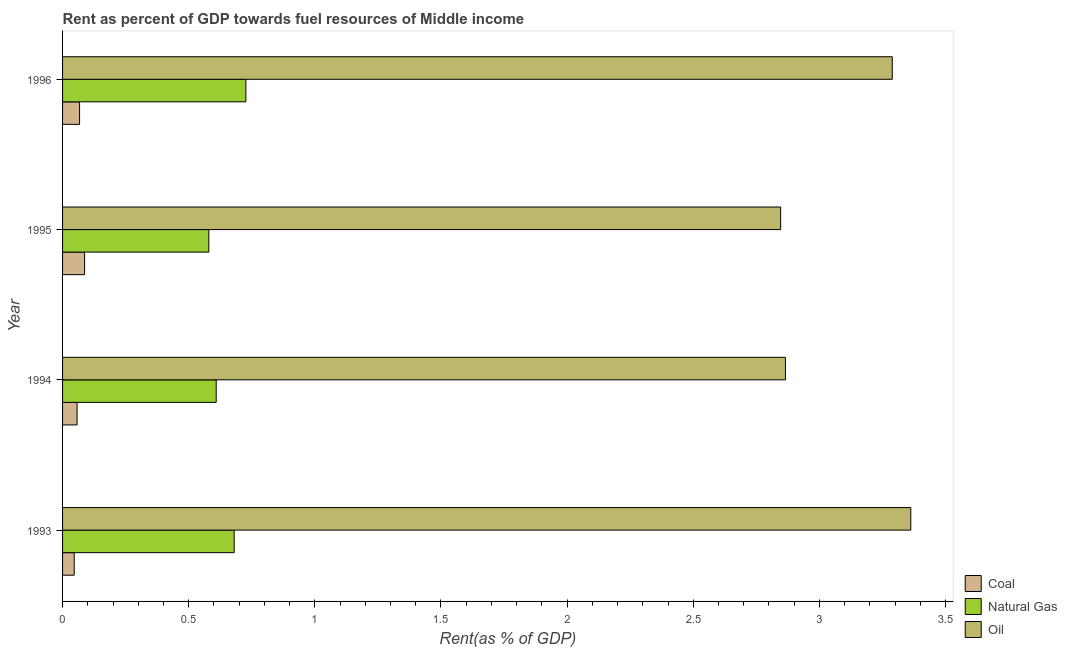Are the number of bars on each tick of the Y-axis equal?
Offer a very short reply. Yes. What is the rent towards oil in 1995?
Offer a very short reply. 2.85. Across all years, what is the maximum rent towards oil?
Your response must be concise. 3.36. Across all years, what is the minimum rent towards oil?
Keep it short and to the point. 2.85. What is the total rent towards natural gas in the graph?
Give a very brief answer. 2.6. What is the difference between the rent towards oil in 1994 and that in 1995?
Your answer should be compact. 0.02. What is the difference between the rent towards coal in 1994 and the rent towards oil in 1995?
Give a very brief answer. -2.79. What is the average rent towards coal per year?
Offer a terse response. 0.07. In the year 1993, what is the difference between the rent towards natural gas and rent towards oil?
Provide a succinct answer. -2.68. What is the ratio of the rent towards oil in 1993 to that in 1994?
Your answer should be compact. 1.17. What is the difference between the highest and the second highest rent towards natural gas?
Ensure brevity in your answer.  0.05. What is the difference between the highest and the lowest rent towards oil?
Ensure brevity in your answer.  0.52. Is the sum of the rent towards natural gas in 1993 and 1994 greater than the maximum rent towards coal across all years?
Offer a terse response. Yes. What does the 1st bar from the top in 1996 represents?
Give a very brief answer. Oil. What does the 2nd bar from the bottom in 1995 represents?
Your answer should be compact. Natural Gas. Is it the case that in every year, the sum of the rent towards coal and rent towards natural gas is greater than the rent towards oil?
Your answer should be very brief. No. How many bars are there?
Your answer should be compact. 12. Are all the bars in the graph horizontal?
Offer a very short reply. Yes. How many years are there in the graph?
Your answer should be very brief. 4. Does the graph contain any zero values?
Give a very brief answer. No. Does the graph contain grids?
Offer a terse response. No. How are the legend labels stacked?
Give a very brief answer. Vertical. What is the title of the graph?
Provide a short and direct response. Rent as percent of GDP towards fuel resources of Middle income. Does "Negligence towards kids" appear as one of the legend labels in the graph?
Make the answer very short. No. What is the label or title of the X-axis?
Provide a short and direct response. Rent(as % of GDP). What is the label or title of the Y-axis?
Make the answer very short. Year. What is the Rent(as % of GDP) of Coal in 1993?
Give a very brief answer. 0.05. What is the Rent(as % of GDP) in Natural Gas in 1993?
Provide a short and direct response. 0.68. What is the Rent(as % of GDP) of Oil in 1993?
Make the answer very short. 3.36. What is the Rent(as % of GDP) of Coal in 1994?
Ensure brevity in your answer.  0.06. What is the Rent(as % of GDP) in Natural Gas in 1994?
Make the answer very short. 0.61. What is the Rent(as % of GDP) of Oil in 1994?
Your response must be concise. 2.87. What is the Rent(as % of GDP) of Coal in 1995?
Offer a very short reply. 0.09. What is the Rent(as % of GDP) of Natural Gas in 1995?
Keep it short and to the point. 0.58. What is the Rent(as % of GDP) in Oil in 1995?
Keep it short and to the point. 2.85. What is the Rent(as % of GDP) in Coal in 1996?
Ensure brevity in your answer.  0.07. What is the Rent(as % of GDP) of Natural Gas in 1996?
Your response must be concise. 0.73. What is the Rent(as % of GDP) in Oil in 1996?
Give a very brief answer. 3.29. Across all years, what is the maximum Rent(as % of GDP) of Coal?
Offer a very short reply. 0.09. Across all years, what is the maximum Rent(as % of GDP) of Natural Gas?
Your answer should be very brief. 0.73. Across all years, what is the maximum Rent(as % of GDP) in Oil?
Offer a terse response. 3.36. Across all years, what is the minimum Rent(as % of GDP) of Coal?
Make the answer very short. 0.05. Across all years, what is the minimum Rent(as % of GDP) of Natural Gas?
Give a very brief answer. 0.58. Across all years, what is the minimum Rent(as % of GDP) of Oil?
Keep it short and to the point. 2.85. What is the total Rent(as % of GDP) in Coal in the graph?
Keep it short and to the point. 0.26. What is the total Rent(as % of GDP) in Natural Gas in the graph?
Make the answer very short. 2.6. What is the total Rent(as % of GDP) of Oil in the graph?
Offer a very short reply. 12.36. What is the difference between the Rent(as % of GDP) of Coal in 1993 and that in 1994?
Keep it short and to the point. -0.01. What is the difference between the Rent(as % of GDP) of Natural Gas in 1993 and that in 1994?
Your response must be concise. 0.07. What is the difference between the Rent(as % of GDP) in Oil in 1993 and that in 1994?
Your answer should be very brief. 0.5. What is the difference between the Rent(as % of GDP) of Coal in 1993 and that in 1995?
Provide a short and direct response. -0.04. What is the difference between the Rent(as % of GDP) in Natural Gas in 1993 and that in 1995?
Your answer should be compact. 0.1. What is the difference between the Rent(as % of GDP) in Oil in 1993 and that in 1995?
Provide a short and direct response. 0.52. What is the difference between the Rent(as % of GDP) in Coal in 1993 and that in 1996?
Your response must be concise. -0.02. What is the difference between the Rent(as % of GDP) in Natural Gas in 1993 and that in 1996?
Make the answer very short. -0.05. What is the difference between the Rent(as % of GDP) in Oil in 1993 and that in 1996?
Offer a very short reply. 0.07. What is the difference between the Rent(as % of GDP) in Coal in 1994 and that in 1995?
Make the answer very short. -0.03. What is the difference between the Rent(as % of GDP) of Natural Gas in 1994 and that in 1995?
Provide a succinct answer. 0.03. What is the difference between the Rent(as % of GDP) in Oil in 1994 and that in 1995?
Give a very brief answer. 0.02. What is the difference between the Rent(as % of GDP) of Coal in 1994 and that in 1996?
Ensure brevity in your answer.  -0.01. What is the difference between the Rent(as % of GDP) of Natural Gas in 1994 and that in 1996?
Offer a very short reply. -0.12. What is the difference between the Rent(as % of GDP) in Oil in 1994 and that in 1996?
Provide a succinct answer. -0.42. What is the difference between the Rent(as % of GDP) in Coal in 1995 and that in 1996?
Make the answer very short. 0.02. What is the difference between the Rent(as % of GDP) of Natural Gas in 1995 and that in 1996?
Provide a short and direct response. -0.15. What is the difference between the Rent(as % of GDP) in Oil in 1995 and that in 1996?
Make the answer very short. -0.44. What is the difference between the Rent(as % of GDP) of Coal in 1993 and the Rent(as % of GDP) of Natural Gas in 1994?
Give a very brief answer. -0.56. What is the difference between the Rent(as % of GDP) in Coal in 1993 and the Rent(as % of GDP) in Oil in 1994?
Make the answer very short. -2.82. What is the difference between the Rent(as % of GDP) of Natural Gas in 1993 and the Rent(as % of GDP) of Oil in 1994?
Make the answer very short. -2.19. What is the difference between the Rent(as % of GDP) of Coal in 1993 and the Rent(as % of GDP) of Natural Gas in 1995?
Give a very brief answer. -0.53. What is the difference between the Rent(as % of GDP) in Coal in 1993 and the Rent(as % of GDP) in Oil in 1995?
Provide a succinct answer. -2.8. What is the difference between the Rent(as % of GDP) in Natural Gas in 1993 and the Rent(as % of GDP) in Oil in 1995?
Provide a short and direct response. -2.17. What is the difference between the Rent(as % of GDP) of Coal in 1993 and the Rent(as % of GDP) of Natural Gas in 1996?
Your answer should be compact. -0.68. What is the difference between the Rent(as % of GDP) in Coal in 1993 and the Rent(as % of GDP) in Oil in 1996?
Give a very brief answer. -3.24. What is the difference between the Rent(as % of GDP) of Natural Gas in 1993 and the Rent(as % of GDP) of Oil in 1996?
Make the answer very short. -2.61. What is the difference between the Rent(as % of GDP) in Coal in 1994 and the Rent(as % of GDP) in Natural Gas in 1995?
Provide a short and direct response. -0.52. What is the difference between the Rent(as % of GDP) of Coal in 1994 and the Rent(as % of GDP) of Oil in 1995?
Ensure brevity in your answer.  -2.79. What is the difference between the Rent(as % of GDP) of Natural Gas in 1994 and the Rent(as % of GDP) of Oil in 1995?
Your response must be concise. -2.24. What is the difference between the Rent(as % of GDP) in Coal in 1994 and the Rent(as % of GDP) in Natural Gas in 1996?
Offer a very short reply. -0.67. What is the difference between the Rent(as % of GDP) of Coal in 1994 and the Rent(as % of GDP) of Oil in 1996?
Your response must be concise. -3.23. What is the difference between the Rent(as % of GDP) in Natural Gas in 1994 and the Rent(as % of GDP) in Oil in 1996?
Give a very brief answer. -2.68. What is the difference between the Rent(as % of GDP) in Coal in 1995 and the Rent(as % of GDP) in Natural Gas in 1996?
Your answer should be very brief. -0.64. What is the difference between the Rent(as % of GDP) of Coal in 1995 and the Rent(as % of GDP) of Oil in 1996?
Provide a short and direct response. -3.2. What is the difference between the Rent(as % of GDP) in Natural Gas in 1995 and the Rent(as % of GDP) in Oil in 1996?
Provide a succinct answer. -2.71. What is the average Rent(as % of GDP) of Coal per year?
Your answer should be very brief. 0.06. What is the average Rent(as % of GDP) in Natural Gas per year?
Your response must be concise. 0.65. What is the average Rent(as % of GDP) of Oil per year?
Provide a succinct answer. 3.09. In the year 1993, what is the difference between the Rent(as % of GDP) in Coal and Rent(as % of GDP) in Natural Gas?
Provide a succinct answer. -0.63. In the year 1993, what is the difference between the Rent(as % of GDP) of Coal and Rent(as % of GDP) of Oil?
Your answer should be compact. -3.32. In the year 1993, what is the difference between the Rent(as % of GDP) of Natural Gas and Rent(as % of GDP) of Oil?
Offer a terse response. -2.68. In the year 1994, what is the difference between the Rent(as % of GDP) in Coal and Rent(as % of GDP) in Natural Gas?
Ensure brevity in your answer.  -0.55. In the year 1994, what is the difference between the Rent(as % of GDP) of Coal and Rent(as % of GDP) of Oil?
Your answer should be compact. -2.81. In the year 1994, what is the difference between the Rent(as % of GDP) in Natural Gas and Rent(as % of GDP) in Oil?
Give a very brief answer. -2.26. In the year 1995, what is the difference between the Rent(as % of GDP) of Coal and Rent(as % of GDP) of Natural Gas?
Offer a very short reply. -0.49. In the year 1995, what is the difference between the Rent(as % of GDP) in Coal and Rent(as % of GDP) in Oil?
Ensure brevity in your answer.  -2.76. In the year 1995, what is the difference between the Rent(as % of GDP) of Natural Gas and Rent(as % of GDP) of Oil?
Your answer should be compact. -2.27. In the year 1996, what is the difference between the Rent(as % of GDP) in Coal and Rent(as % of GDP) in Natural Gas?
Give a very brief answer. -0.66. In the year 1996, what is the difference between the Rent(as % of GDP) in Coal and Rent(as % of GDP) in Oil?
Ensure brevity in your answer.  -3.22. In the year 1996, what is the difference between the Rent(as % of GDP) in Natural Gas and Rent(as % of GDP) in Oil?
Give a very brief answer. -2.56. What is the ratio of the Rent(as % of GDP) of Coal in 1993 to that in 1994?
Ensure brevity in your answer.  0.8. What is the ratio of the Rent(as % of GDP) in Natural Gas in 1993 to that in 1994?
Provide a succinct answer. 1.12. What is the ratio of the Rent(as % of GDP) in Oil in 1993 to that in 1994?
Offer a very short reply. 1.17. What is the ratio of the Rent(as % of GDP) in Coal in 1993 to that in 1995?
Offer a terse response. 0.53. What is the ratio of the Rent(as % of GDP) in Natural Gas in 1993 to that in 1995?
Make the answer very short. 1.17. What is the ratio of the Rent(as % of GDP) in Oil in 1993 to that in 1995?
Provide a short and direct response. 1.18. What is the ratio of the Rent(as % of GDP) in Coal in 1993 to that in 1996?
Ensure brevity in your answer.  0.68. What is the ratio of the Rent(as % of GDP) of Natural Gas in 1993 to that in 1996?
Make the answer very short. 0.94. What is the ratio of the Rent(as % of GDP) in Oil in 1993 to that in 1996?
Ensure brevity in your answer.  1.02. What is the ratio of the Rent(as % of GDP) in Coal in 1994 to that in 1995?
Ensure brevity in your answer.  0.66. What is the ratio of the Rent(as % of GDP) of Natural Gas in 1994 to that in 1995?
Make the answer very short. 1.05. What is the ratio of the Rent(as % of GDP) in Coal in 1994 to that in 1996?
Offer a terse response. 0.85. What is the ratio of the Rent(as % of GDP) of Natural Gas in 1994 to that in 1996?
Give a very brief answer. 0.84. What is the ratio of the Rent(as % of GDP) of Oil in 1994 to that in 1996?
Make the answer very short. 0.87. What is the ratio of the Rent(as % of GDP) of Coal in 1995 to that in 1996?
Make the answer very short. 1.29. What is the ratio of the Rent(as % of GDP) in Natural Gas in 1995 to that in 1996?
Offer a very short reply. 0.8. What is the ratio of the Rent(as % of GDP) of Oil in 1995 to that in 1996?
Make the answer very short. 0.87. What is the difference between the highest and the second highest Rent(as % of GDP) of Coal?
Offer a terse response. 0.02. What is the difference between the highest and the second highest Rent(as % of GDP) in Natural Gas?
Provide a short and direct response. 0.05. What is the difference between the highest and the second highest Rent(as % of GDP) in Oil?
Your answer should be compact. 0.07. What is the difference between the highest and the lowest Rent(as % of GDP) in Coal?
Offer a terse response. 0.04. What is the difference between the highest and the lowest Rent(as % of GDP) of Natural Gas?
Provide a short and direct response. 0.15. What is the difference between the highest and the lowest Rent(as % of GDP) in Oil?
Make the answer very short. 0.52. 